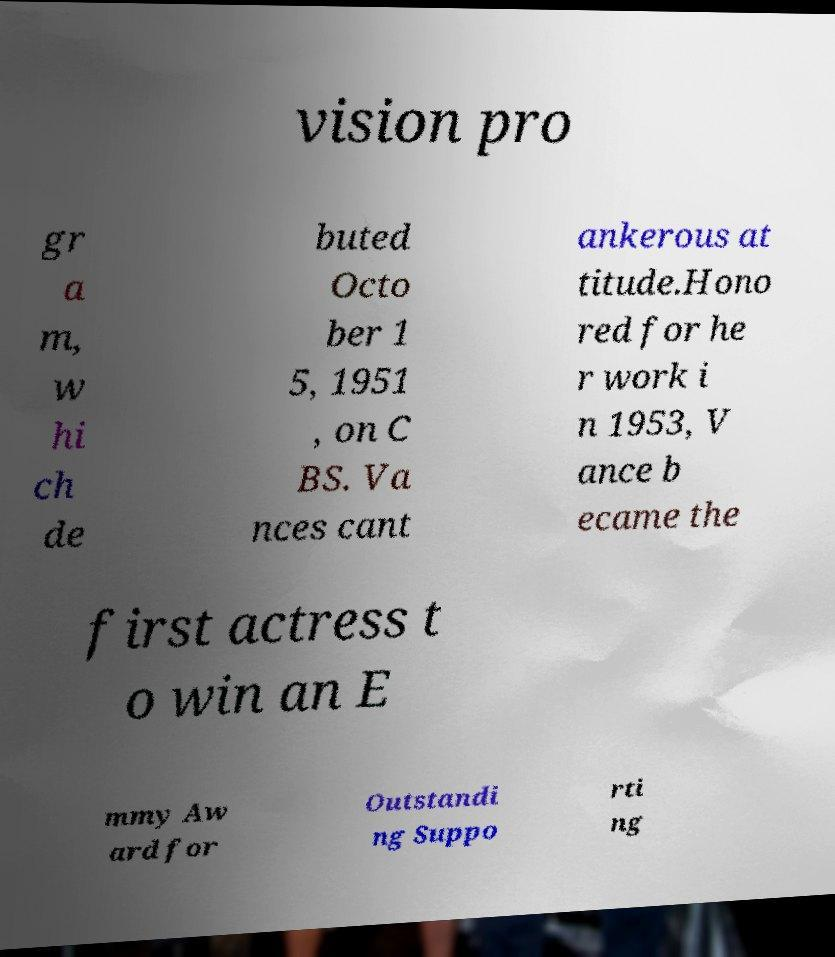For documentation purposes, I need the text within this image transcribed. Could you provide that? vision pro gr a m, w hi ch de buted Octo ber 1 5, 1951 , on C BS. Va nces cant ankerous at titude.Hono red for he r work i n 1953, V ance b ecame the first actress t o win an E mmy Aw ard for Outstandi ng Suppo rti ng 